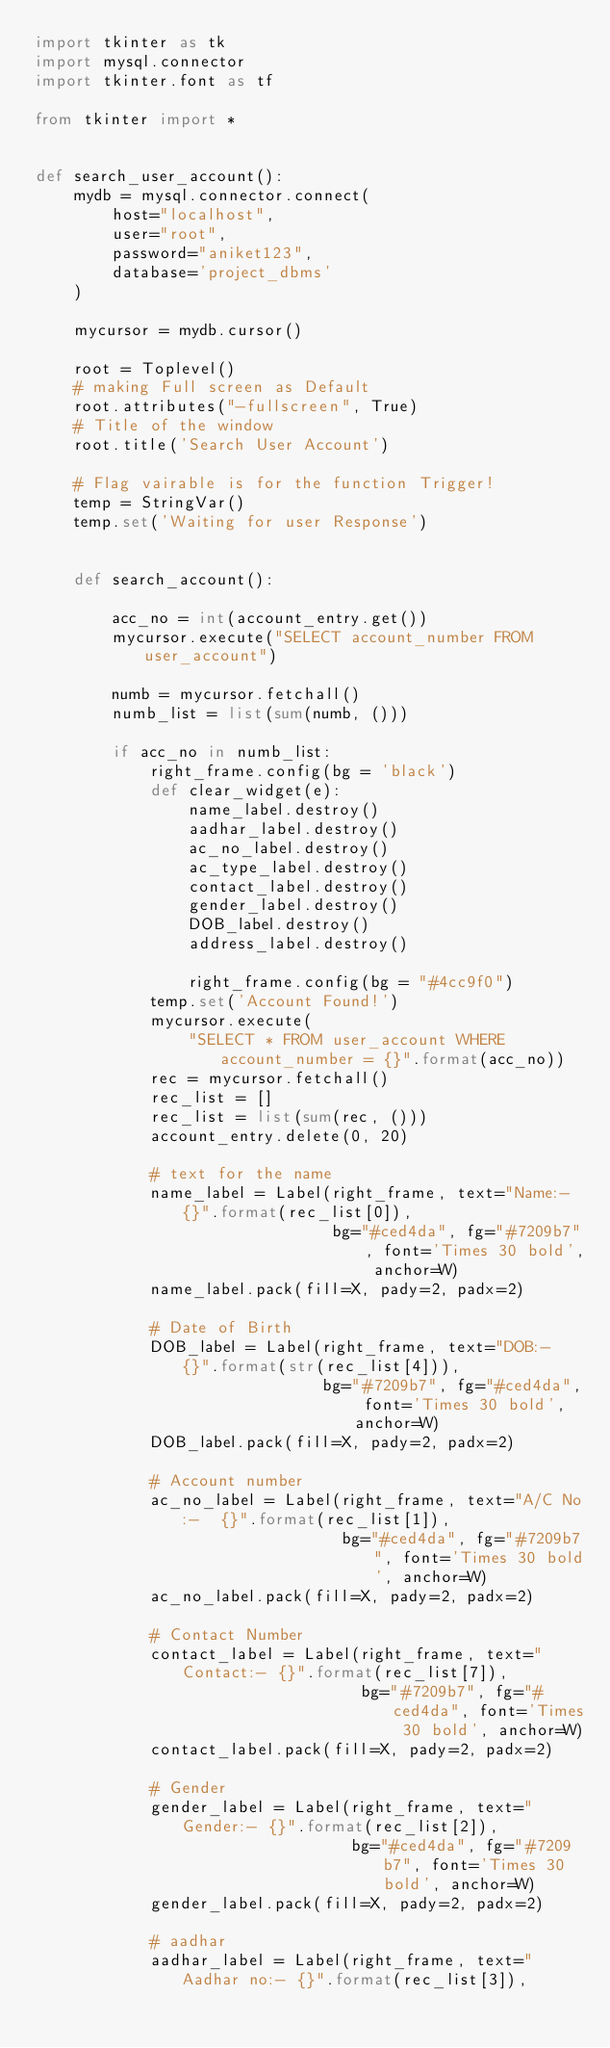<code> <loc_0><loc_0><loc_500><loc_500><_Python_>import tkinter as tk
import mysql.connector
import tkinter.font as tf

from tkinter import *


def search_user_account():
    mydb = mysql.connector.connect(
        host="localhost",
        user="root",
        password="aniket123",
        database='project_dbms'
    )

    mycursor = mydb.cursor()

    root = Toplevel()
    # making Full screen as Default
    root.attributes("-fullscreen", True)
    # Title of the window
    root.title('Search User Account')

    # Flag vairable is for the function Trigger!
    temp = StringVar()
    temp.set('Waiting for user Response')
    
    
    def search_account():
        
        acc_no = int(account_entry.get())
        mycursor.execute("SELECT account_number FROM user_account")

        numb = mycursor.fetchall()
        numb_list = list(sum(numb, ()))

        if acc_no in numb_list:
            right_frame.config(bg = 'black')
            def clear_widget(e):
                name_label.destroy()
                aadhar_label.destroy()
                ac_no_label.destroy()
                ac_type_label.destroy()
                contact_label.destroy()
                gender_label.destroy()
                DOB_label.destroy()
                address_label.destroy()

                right_frame.config(bg = "#4cc9f0")
            temp.set('Account Found!')
            mycursor.execute(
                "SELECT * FROM user_account WHERE account_number = {}".format(acc_no))
            rec = mycursor.fetchall()
            rec_list = []
            rec_list = list(sum(rec, ()))
            account_entry.delete(0, 20)

            # text for the name
            name_label = Label(right_frame, text="Name:- {}".format(rec_list[0]),
                               bg="#ced4da", fg="#7209b7", font='Times 30 bold', anchor=W)
            name_label.pack(fill=X, pady=2, padx=2)

            # Date of Birth
            DOB_label = Label(right_frame, text="DOB:-  {}".format(str(rec_list[4])),
                              bg="#7209b7", fg="#ced4da", font='Times 30 bold', anchor=W)
            DOB_label.pack(fill=X, pady=2, padx=2)

            # Account number
            ac_no_label = Label(right_frame, text="A/C No:-  {}".format(rec_list[1]),
                                bg="#ced4da", fg="#7209b7", font='Times 30 bold', anchor=W)
            ac_no_label.pack(fill=X, pady=2, padx=2)

            # Contact Number
            contact_label = Label(right_frame, text="Contact:- {}".format(rec_list[7]),
                                  bg="#7209b7", fg="#ced4da", font='Times 30 bold', anchor=W)
            contact_label.pack(fill=X, pady=2, padx=2)

            # Gender
            gender_label = Label(right_frame, text="Gender:- {}".format(rec_list[2]),
                                 bg="#ced4da", fg="#7209b7", font='Times 30 bold', anchor=W)
            gender_label.pack(fill=X, pady=2, padx=2)

            # aadhar
            aadhar_label = Label(right_frame, text="Aadhar no:- {}".format(rec_list[3]),</code> 